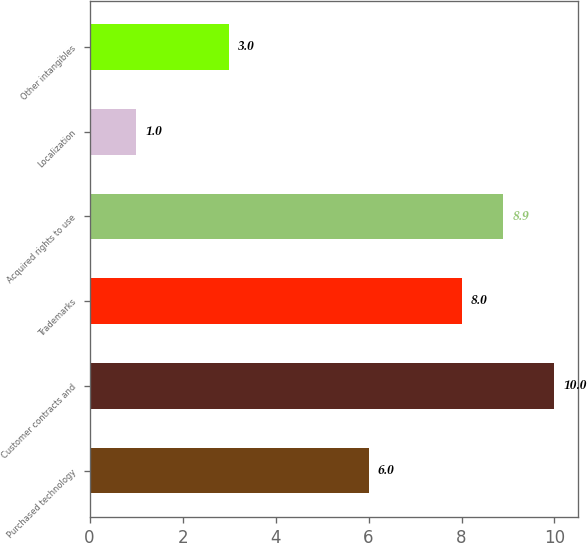Convert chart. <chart><loc_0><loc_0><loc_500><loc_500><bar_chart><fcel>Purchased technology<fcel>Customer contracts and<fcel>Trademarks<fcel>Acquired rights to use<fcel>Localization<fcel>Other intangibles<nl><fcel>6<fcel>10<fcel>8<fcel>8.9<fcel>1<fcel>3<nl></chart> 